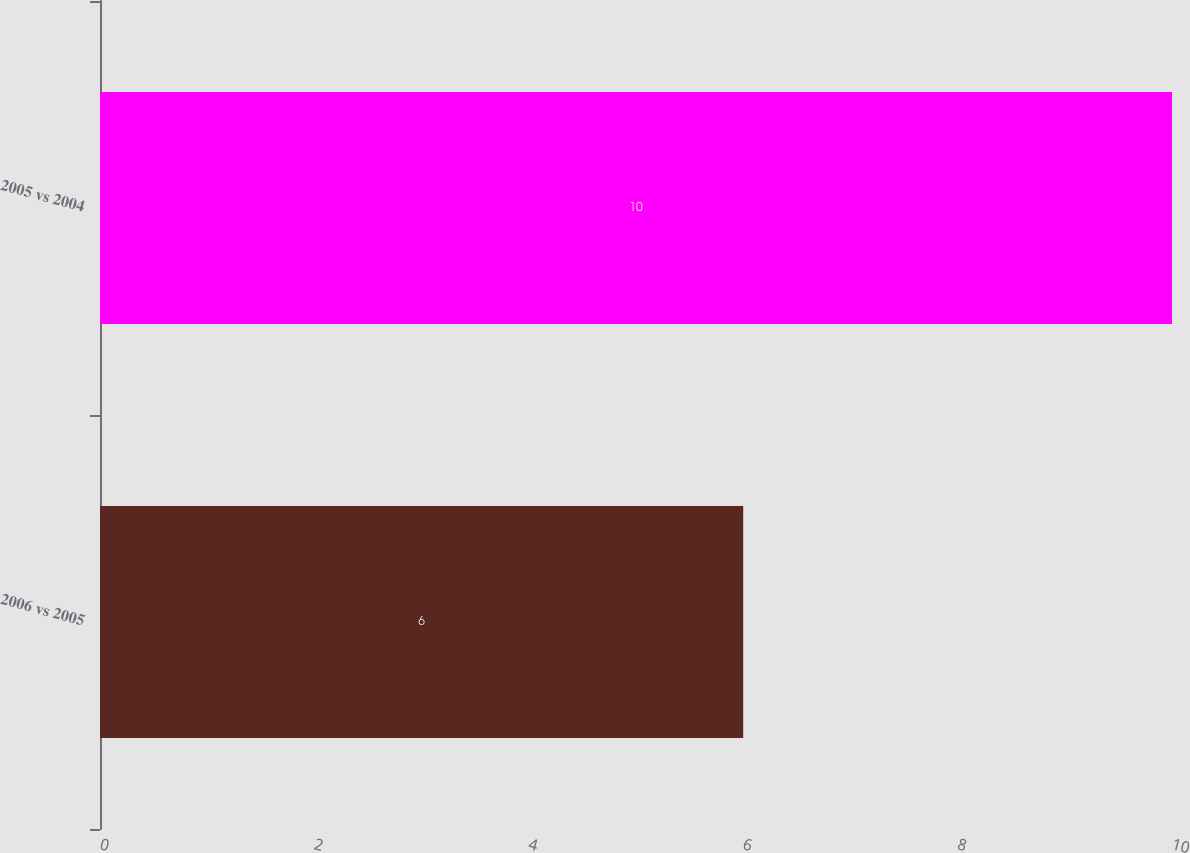<chart> <loc_0><loc_0><loc_500><loc_500><bar_chart><fcel>2006 vs 2005<fcel>2005 vs 2004<nl><fcel>6<fcel>10<nl></chart> 